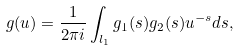<formula> <loc_0><loc_0><loc_500><loc_500>g ( u ) = \frac { 1 } { 2 \pi i } \int _ { l _ { 1 } } g _ { 1 } ( s ) g _ { 2 } ( s ) u ^ { - s } d s ,</formula> 